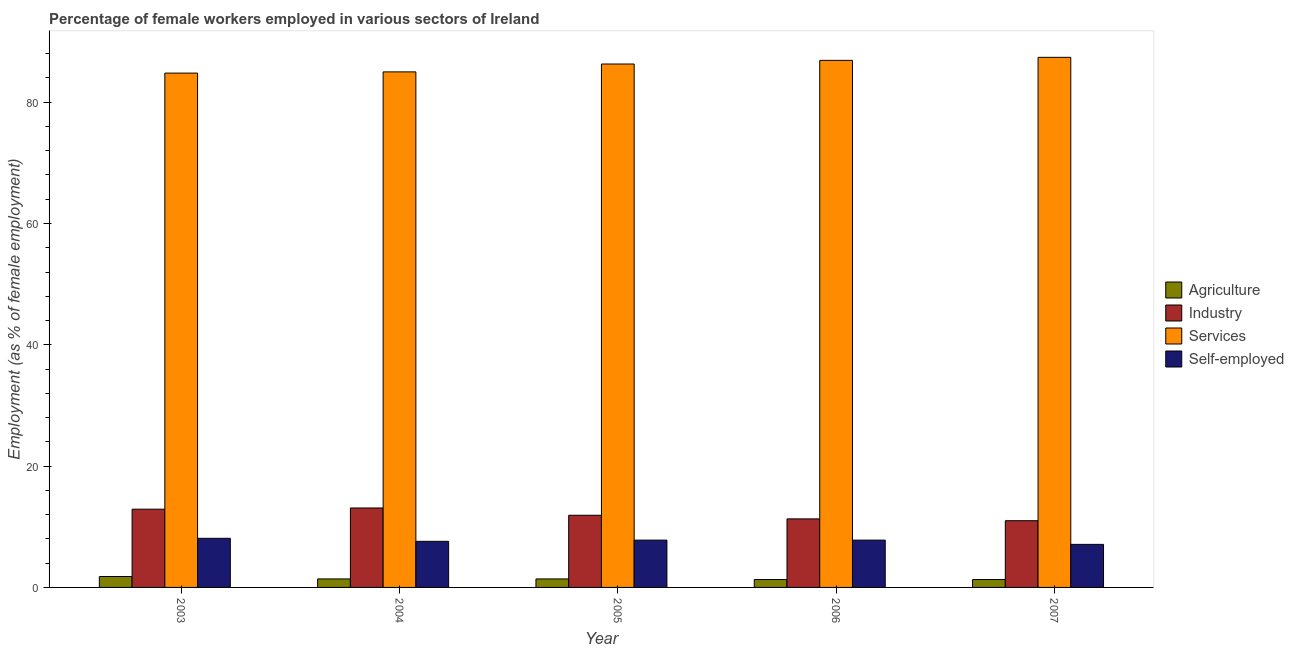How many different coloured bars are there?
Offer a very short reply. 4. How many groups of bars are there?
Your answer should be compact. 5. Are the number of bars on each tick of the X-axis equal?
Offer a very short reply. Yes. How many bars are there on the 4th tick from the left?
Provide a short and direct response. 4. How many bars are there on the 1st tick from the right?
Provide a short and direct response. 4. What is the percentage of self employed female workers in 2004?
Offer a terse response. 7.6. Across all years, what is the maximum percentage of female workers in industry?
Provide a short and direct response. 13.1. Across all years, what is the minimum percentage of female workers in industry?
Provide a succinct answer. 11. What is the total percentage of self employed female workers in the graph?
Your answer should be compact. 38.4. What is the difference between the percentage of female workers in services in 2005 and that in 2006?
Your answer should be very brief. -0.6. What is the difference between the percentage of female workers in industry in 2003 and the percentage of female workers in services in 2006?
Ensure brevity in your answer.  1.6. What is the average percentage of female workers in industry per year?
Make the answer very short. 12.04. In the year 2003, what is the difference between the percentage of female workers in agriculture and percentage of female workers in industry?
Offer a terse response. 0. What is the ratio of the percentage of self employed female workers in 2004 to that in 2005?
Ensure brevity in your answer.  0.97. Is the percentage of self employed female workers in 2005 less than that in 2006?
Give a very brief answer. No. Is the difference between the percentage of self employed female workers in 2004 and 2005 greater than the difference between the percentage of female workers in services in 2004 and 2005?
Provide a succinct answer. No. What is the difference between the highest and the second highest percentage of female workers in industry?
Offer a terse response. 0.2. What is the difference between the highest and the lowest percentage of self employed female workers?
Your response must be concise. 1. In how many years, is the percentage of female workers in services greater than the average percentage of female workers in services taken over all years?
Offer a very short reply. 3. Is the sum of the percentage of self employed female workers in 2005 and 2007 greater than the maximum percentage of female workers in services across all years?
Your response must be concise. Yes. Is it the case that in every year, the sum of the percentage of female workers in agriculture and percentage of female workers in industry is greater than the sum of percentage of self employed female workers and percentage of female workers in services?
Your answer should be compact. No. What does the 2nd bar from the left in 2003 represents?
Make the answer very short. Industry. What does the 2nd bar from the right in 2006 represents?
Offer a very short reply. Services. How many years are there in the graph?
Give a very brief answer. 5. Does the graph contain grids?
Your answer should be compact. No. How many legend labels are there?
Your answer should be very brief. 4. What is the title of the graph?
Your answer should be very brief. Percentage of female workers employed in various sectors of Ireland. Does "UNPBF" appear as one of the legend labels in the graph?
Keep it short and to the point. No. What is the label or title of the Y-axis?
Your answer should be very brief. Employment (as % of female employment). What is the Employment (as % of female employment) in Agriculture in 2003?
Your answer should be very brief. 1.8. What is the Employment (as % of female employment) of Industry in 2003?
Provide a short and direct response. 12.9. What is the Employment (as % of female employment) in Services in 2003?
Your response must be concise. 84.8. What is the Employment (as % of female employment) in Self-employed in 2003?
Your answer should be very brief. 8.1. What is the Employment (as % of female employment) in Agriculture in 2004?
Give a very brief answer. 1.4. What is the Employment (as % of female employment) of Industry in 2004?
Your response must be concise. 13.1. What is the Employment (as % of female employment) in Self-employed in 2004?
Offer a very short reply. 7.6. What is the Employment (as % of female employment) of Agriculture in 2005?
Provide a succinct answer. 1.4. What is the Employment (as % of female employment) in Industry in 2005?
Your answer should be compact. 11.9. What is the Employment (as % of female employment) in Services in 2005?
Keep it short and to the point. 86.3. What is the Employment (as % of female employment) in Self-employed in 2005?
Ensure brevity in your answer.  7.8. What is the Employment (as % of female employment) in Agriculture in 2006?
Your answer should be very brief. 1.3. What is the Employment (as % of female employment) in Industry in 2006?
Your response must be concise. 11.3. What is the Employment (as % of female employment) of Services in 2006?
Offer a very short reply. 86.9. What is the Employment (as % of female employment) in Self-employed in 2006?
Offer a terse response. 7.8. What is the Employment (as % of female employment) in Agriculture in 2007?
Offer a terse response. 1.3. What is the Employment (as % of female employment) of Services in 2007?
Keep it short and to the point. 87.4. What is the Employment (as % of female employment) of Self-employed in 2007?
Provide a short and direct response. 7.1. Across all years, what is the maximum Employment (as % of female employment) of Agriculture?
Your response must be concise. 1.8. Across all years, what is the maximum Employment (as % of female employment) in Industry?
Provide a short and direct response. 13.1. Across all years, what is the maximum Employment (as % of female employment) of Services?
Offer a terse response. 87.4. Across all years, what is the maximum Employment (as % of female employment) in Self-employed?
Ensure brevity in your answer.  8.1. Across all years, what is the minimum Employment (as % of female employment) in Agriculture?
Give a very brief answer. 1.3. Across all years, what is the minimum Employment (as % of female employment) in Services?
Ensure brevity in your answer.  84.8. Across all years, what is the minimum Employment (as % of female employment) in Self-employed?
Your answer should be very brief. 7.1. What is the total Employment (as % of female employment) in Agriculture in the graph?
Make the answer very short. 7.2. What is the total Employment (as % of female employment) in Industry in the graph?
Provide a succinct answer. 60.2. What is the total Employment (as % of female employment) in Services in the graph?
Make the answer very short. 430.4. What is the total Employment (as % of female employment) in Self-employed in the graph?
Ensure brevity in your answer.  38.4. What is the difference between the Employment (as % of female employment) of Agriculture in 2003 and that in 2004?
Provide a short and direct response. 0.4. What is the difference between the Employment (as % of female employment) of Industry in 2003 and that in 2004?
Provide a succinct answer. -0.2. What is the difference between the Employment (as % of female employment) in Services in 2003 and that in 2004?
Your answer should be very brief. -0.2. What is the difference between the Employment (as % of female employment) in Self-employed in 2003 and that in 2005?
Make the answer very short. 0.3. What is the difference between the Employment (as % of female employment) in Agriculture in 2003 and that in 2006?
Your response must be concise. 0.5. What is the difference between the Employment (as % of female employment) of Services in 2003 and that in 2006?
Offer a very short reply. -2.1. What is the difference between the Employment (as % of female employment) of Self-employed in 2003 and that in 2006?
Give a very brief answer. 0.3. What is the difference between the Employment (as % of female employment) in Industry in 2003 and that in 2007?
Your answer should be very brief. 1.9. What is the difference between the Employment (as % of female employment) of Self-employed in 2003 and that in 2007?
Offer a very short reply. 1. What is the difference between the Employment (as % of female employment) in Industry in 2004 and that in 2005?
Your answer should be compact. 1.2. What is the difference between the Employment (as % of female employment) of Self-employed in 2004 and that in 2005?
Ensure brevity in your answer.  -0.2. What is the difference between the Employment (as % of female employment) of Industry in 2004 and that in 2007?
Your answer should be compact. 2.1. What is the difference between the Employment (as % of female employment) in Self-employed in 2004 and that in 2007?
Keep it short and to the point. 0.5. What is the difference between the Employment (as % of female employment) in Industry in 2005 and that in 2007?
Offer a very short reply. 0.9. What is the difference between the Employment (as % of female employment) of Services in 2005 and that in 2007?
Make the answer very short. -1.1. What is the difference between the Employment (as % of female employment) in Self-employed in 2006 and that in 2007?
Ensure brevity in your answer.  0.7. What is the difference between the Employment (as % of female employment) in Agriculture in 2003 and the Employment (as % of female employment) in Services in 2004?
Keep it short and to the point. -83.2. What is the difference between the Employment (as % of female employment) in Agriculture in 2003 and the Employment (as % of female employment) in Self-employed in 2004?
Your response must be concise. -5.8. What is the difference between the Employment (as % of female employment) in Industry in 2003 and the Employment (as % of female employment) in Services in 2004?
Ensure brevity in your answer.  -72.1. What is the difference between the Employment (as % of female employment) in Services in 2003 and the Employment (as % of female employment) in Self-employed in 2004?
Offer a very short reply. 77.2. What is the difference between the Employment (as % of female employment) in Agriculture in 2003 and the Employment (as % of female employment) in Services in 2005?
Your response must be concise. -84.5. What is the difference between the Employment (as % of female employment) in Agriculture in 2003 and the Employment (as % of female employment) in Self-employed in 2005?
Keep it short and to the point. -6. What is the difference between the Employment (as % of female employment) of Industry in 2003 and the Employment (as % of female employment) of Services in 2005?
Offer a very short reply. -73.4. What is the difference between the Employment (as % of female employment) of Agriculture in 2003 and the Employment (as % of female employment) of Services in 2006?
Your answer should be compact. -85.1. What is the difference between the Employment (as % of female employment) in Agriculture in 2003 and the Employment (as % of female employment) in Self-employed in 2006?
Provide a succinct answer. -6. What is the difference between the Employment (as % of female employment) in Industry in 2003 and the Employment (as % of female employment) in Services in 2006?
Make the answer very short. -74. What is the difference between the Employment (as % of female employment) of Agriculture in 2003 and the Employment (as % of female employment) of Services in 2007?
Offer a very short reply. -85.6. What is the difference between the Employment (as % of female employment) of Agriculture in 2003 and the Employment (as % of female employment) of Self-employed in 2007?
Your response must be concise. -5.3. What is the difference between the Employment (as % of female employment) in Industry in 2003 and the Employment (as % of female employment) in Services in 2007?
Your answer should be very brief. -74.5. What is the difference between the Employment (as % of female employment) in Services in 2003 and the Employment (as % of female employment) in Self-employed in 2007?
Offer a very short reply. 77.7. What is the difference between the Employment (as % of female employment) in Agriculture in 2004 and the Employment (as % of female employment) in Industry in 2005?
Ensure brevity in your answer.  -10.5. What is the difference between the Employment (as % of female employment) in Agriculture in 2004 and the Employment (as % of female employment) in Services in 2005?
Provide a succinct answer. -84.9. What is the difference between the Employment (as % of female employment) of Agriculture in 2004 and the Employment (as % of female employment) of Self-employed in 2005?
Your answer should be very brief. -6.4. What is the difference between the Employment (as % of female employment) of Industry in 2004 and the Employment (as % of female employment) of Services in 2005?
Your answer should be compact. -73.2. What is the difference between the Employment (as % of female employment) of Services in 2004 and the Employment (as % of female employment) of Self-employed in 2005?
Offer a terse response. 77.2. What is the difference between the Employment (as % of female employment) in Agriculture in 2004 and the Employment (as % of female employment) in Industry in 2006?
Keep it short and to the point. -9.9. What is the difference between the Employment (as % of female employment) of Agriculture in 2004 and the Employment (as % of female employment) of Services in 2006?
Offer a terse response. -85.5. What is the difference between the Employment (as % of female employment) of Industry in 2004 and the Employment (as % of female employment) of Services in 2006?
Offer a very short reply. -73.8. What is the difference between the Employment (as % of female employment) in Services in 2004 and the Employment (as % of female employment) in Self-employed in 2006?
Your response must be concise. 77.2. What is the difference between the Employment (as % of female employment) in Agriculture in 2004 and the Employment (as % of female employment) in Services in 2007?
Provide a succinct answer. -86. What is the difference between the Employment (as % of female employment) of Industry in 2004 and the Employment (as % of female employment) of Services in 2007?
Ensure brevity in your answer.  -74.3. What is the difference between the Employment (as % of female employment) of Services in 2004 and the Employment (as % of female employment) of Self-employed in 2007?
Your response must be concise. 77.9. What is the difference between the Employment (as % of female employment) in Agriculture in 2005 and the Employment (as % of female employment) in Industry in 2006?
Offer a very short reply. -9.9. What is the difference between the Employment (as % of female employment) of Agriculture in 2005 and the Employment (as % of female employment) of Services in 2006?
Your answer should be very brief. -85.5. What is the difference between the Employment (as % of female employment) in Agriculture in 2005 and the Employment (as % of female employment) in Self-employed in 2006?
Offer a very short reply. -6.4. What is the difference between the Employment (as % of female employment) in Industry in 2005 and the Employment (as % of female employment) in Services in 2006?
Offer a terse response. -75. What is the difference between the Employment (as % of female employment) of Services in 2005 and the Employment (as % of female employment) of Self-employed in 2006?
Your answer should be very brief. 78.5. What is the difference between the Employment (as % of female employment) in Agriculture in 2005 and the Employment (as % of female employment) in Services in 2007?
Provide a succinct answer. -86. What is the difference between the Employment (as % of female employment) in Industry in 2005 and the Employment (as % of female employment) in Services in 2007?
Your response must be concise. -75.5. What is the difference between the Employment (as % of female employment) in Services in 2005 and the Employment (as % of female employment) in Self-employed in 2007?
Offer a very short reply. 79.2. What is the difference between the Employment (as % of female employment) in Agriculture in 2006 and the Employment (as % of female employment) in Services in 2007?
Make the answer very short. -86.1. What is the difference between the Employment (as % of female employment) in Agriculture in 2006 and the Employment (as % of female employment) in Self-employed in 2007?
Your answer should be very brief. -5.8. What is the difference between the Employment (as % of female employment) in Industry in 2006 and the Employment (as % of female employment) in Services in 2007?
Your answer should be very brief. -76.1. What is the difference between the Employment (as % of female employment) in Services in 2006 and the Employment (as % of female employment) in Self-employed in 2007?
Your answer should be very brief. 79.8. What is the average Employment (as % of female employment) in Agriculture per year?
Ensure brevity in your answer.  1.44. What is the average Employment (as % of female employment) in Industry per year?
Make the answer very short. 12.04. What is the average Employment (as % of female employment) of Services per year?
Give a very brief answer. 86.08. What is the average Employment (as % of female employment) in Self-employed per year?
Offer a very short reply. 7.68. In the year 2003, what is the difference between the Employment (as % of female employment) of Agriculture and Employment (as % of female employment) of Industry?
Offer a very short reply. -11.1. In the year 2003, what is the difference between the Employment (as % of female employment) of Agriculture and Employment (as % of female employment) of Services?
Offer a terse response. -83. In the year 2003, what is the difference between the Employment (as % of female employment) of Agriculture and Employment (as % of female employment) of Self-employed?
Give a very brief answer. -6.3. In the year 2003, what is the difference between the Employment (as % of female employment) in Industry and Employment (as % of female employment) in Services?
Provide a short and direct response. -71.9. In the year 2003, what is the difference between the Employment (as % of female employment) in Services and Employment (as % of female employment) in Self-employed?
Keep it short and to the point. 76.7. In the year 2004, what is the difference between the Employment (as % of female employment) in Agriculture and Employment (as % of female employment) in Services?
Ensure brevity in your answer.  -83.6. In the year 2004, what is the difference between the Employment (as % of female employment) in Industry and Employment (as % of female employment) in Services?
Provide a short and direct response. -71.9. In the year 2004, what is the difference between the Employment (as % of female employment) of Services and Employment (as % of female employment) of Self-employed?
Offer a very short reply. 77.4. In the year 2005, what is the difference between the Employment (as % of female employment) in Agriculture and Employment (as % of female employment) in Industry?
Keep it short and to the point. -10.5. In the year 2005, what is the difference between the Employment (as % of female employment) in Agriculture and Employment (as % of female employment) in Services?
Provide a short and direct response. -84.9. In the year 2005, what is the difference between the Employment (as % of female employment) of Industry and Employment (as % of female employment) of Services?
Your answer should be very brief. -74.4. In the year 2005, what is the difference between the Employment (as % of female employment) of Services and Employment (as % of female employment) of Self-employed?
Offer a very short reply. 78.5. In the year 2006, what is the difference between the Employment (as % of female employment) of Agriculture and Employment (as % of female employment) of Services?
Provide a short and direct response. -85.6. In the year 2006, what is the difference between the Employment (as % of female employment) in Industry and Employment (as % of female employment) in Services?
Keep it short and to the point. -75.6. In the year 2006, what is the difference between the Employment (as % of female employment) of Services and Employment (as % of female employment) of Self-employed?
Keep it short and to the point. 79.1. In the year 2007, what is the difference between the Employment (as % of female employment) of Agriculture and Employment (as % of female employment) of Services?
Your answer should be compact. -86.1. In the year 2007, what is the difference between the Employment (as % of female employment) of Industry and Employment (as % of female employment) of Services?
Your answer should be very brief. -76.4. In the year 2007, what is the difference between the Employment (as % of female employment) of Industry and Employment (as % of female employment) of Self-employed?
Provide a succinct answer. 3.9. In the year 2007, what is the difference between the Employment (as % of female employment) in Services and Employment (as % of female employment) in Self-employed?
Your answer should be compact. 80.3. What is the ratio of the Employment (as % of female employment) in Industry in 2003 to that in 2004?
Provide a short and direct response. 0.98. What is the ratio of the Employment (as % of female employment) of Services in 2003 to that in 2004?
Make the answer very short. 1. What is the ratio of the Employment (as % of female employment) in Self-employed in 2003 to that in 2004?
Give a very brief answer. 1.07. What is the ratio of the Employment (as % of female employment) of Industry in 2003 to that in 2005?
Your response must be concise. 1.08. What is the ratio of the Employment (as % of female employment) in Services in 2003 to that in 2005?
Offer a very short reply. 0.98. What is the ratio of the Employment (as % of female employment) in Agriculture in 2003 to that in 2006?
Make the answer very short. 1.38. What is the ratio of the Employment (as % of female employment) in Industry in 2003 to that in 2006?
Ensure brevity in your answer.  1.14. What is the ratio of the Employment (as % of female employment) of Services in 2003 to that in 2006?
Give a very brief answer. 0.98. What is the ratio of the Employment (as % of female employment) of Agriculture in 2003 to that in 2007?
Your answer should be very brief. 1.38. What is the ratio of the Employment (as % of female employment) of Industry in 2003 to that in 2007?
Make the answer very short. 1.17. What is the ratio of the Employment (as % of female employment) of Services in 2003 to that in 2007?
Give a very brief answer. 0.97. What is the ratio of the Employment (as % of female employment) in Self-employed in 2003 to that in 2007?
Provide a short and direct response. 1.14. What is the ratio of the Employment (as % of female employment) in Agriculture in 2004 to that in 2005?
Offer a terse response. 1. What is the ratio of the Employment (as % of female employment) of Industry in 2004 to that in 2005?
Your response must be concise. 1.1. What is the ratio of the Employment (as % of female employment) in Services in 2004 to that in 2005?
Your response must be concise. 0.98. What is the ratio of the Employment (as % of female employment) in Self-employed in 2004 to that in 2005?
Provide a short and direct response. 0.97. What is the ratio of the Employment (as % of female employment) in Industry in 2004 to that in 2006?
Keep it short and to the point. 1.16. What is the ratio of the Employment (as % of female employment) of Services in 2004 to that in 2006?
Make the answer very short. 0.98. What is the ratio of the Employment (as % of female employment) of Self-employed in 2004 to that in 2006?
Your answer should be very brief. 0.97. What is the ratio of the Employment (as % of female employment) of Agriculture in 2004 to that in 2007?
Give a very brief answer. 1.08. What is the ratio of the Employment (as % of female employment) in Industry in 2004 to that in 2007?
Provide a succinct answer. 1.19. What is the ratio of the Employment (as % of female employment) of Services in 2004 to that in 2007?
Offer a very short reply. 0.97. What is the ratio of the Employment (as % of female employment) in Self-employed in 2004 to that in 2007?
Give a very brief answer. 1.07. What is the ratio of the Employment (as % of female employment) in Industry in 2005 to that in 2006?
Offer a terse response. 1.05. What is the ratio of the Employment (as % of female employment) in Industry in 2005 to that in 2007?
Your answer should be compact. 1.08. What is the ratio of the Employment (as % of female employment) of Services in 2005 to that in 2007?
Make the answer very short. 0.99. What is the ratio of the Employment (as % of female employment) of Self-employed in 2005 to that in 2007?
Provide a succinct answer. 1.1. What is the ratio of the Employment (as % of female employment) in Industry in 2006 to that in 2007?
Ensure brevity in your answer.  1.03. What is the ratio of the Employment (as % of female employment) of Services in 2006 to that in 2007?
Your answer should be compact. 0.99. What is the ratio of the Employment (as % of female employment) in Self-employed in 2006 to that in 2007?
Offer a very short reply. 1.1. What is the difference between the highest and the second highest Employment (as % of female employment) of Agriculture?
Ensure brevity in your answer.  0.4. What is the difference between the highest and the second highest Employment (as % of female employment) in Industry?
Make the answer very short. 0.2. What is the difference between the highest and the second highest Employment (as % of female employment) of Self-employed?
Your answer should be very brief. 0.3. What is the difference between the highest and the lowest Employment (as % of female employment) of Agriculture?
Your answer should be very brief. 0.5. 